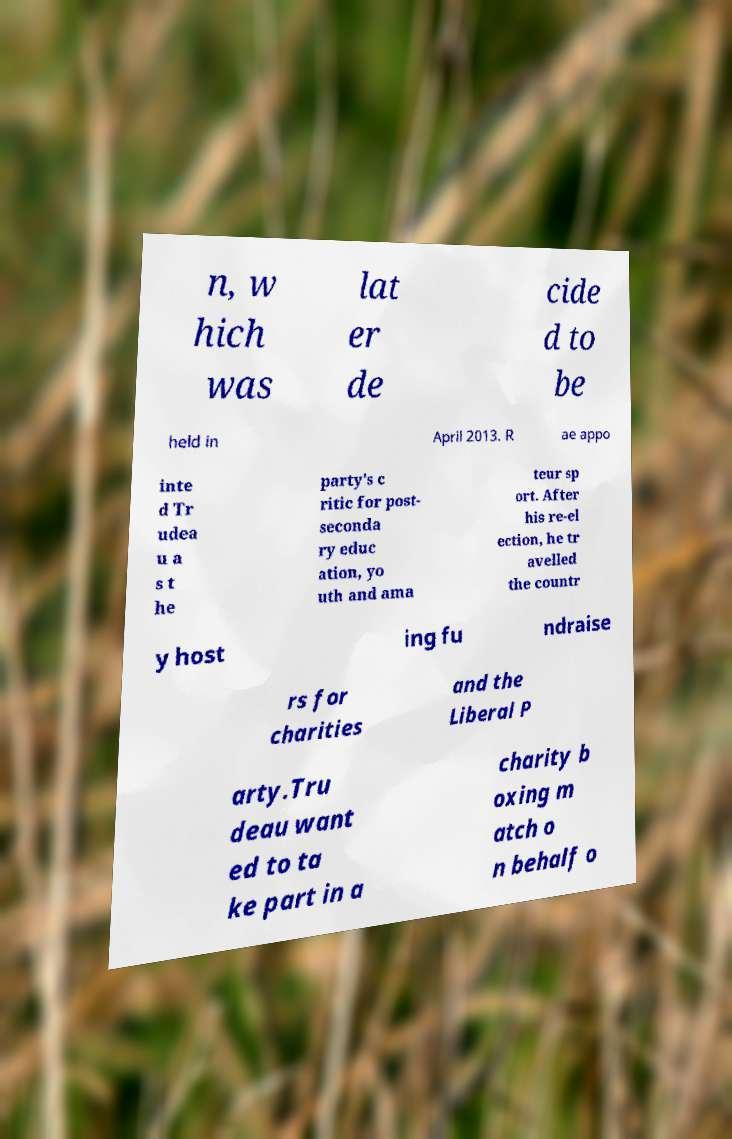Could you assist in decoding the text presented in this image and type it out clearly? n, w hich was lat er de cide d to be held in April 2013. R ae appo inte d Tr udea u a s t he party's c ritic for post- seconda ry educ ation, yo uth and ama teur sp ort. After his re-el ection, he tr avelled the countr y host ing fu ndraise rs for charities and the Liberal P arty.Tru deau want ed to ta ke part in a charity b oxing m atch o n behalf o 